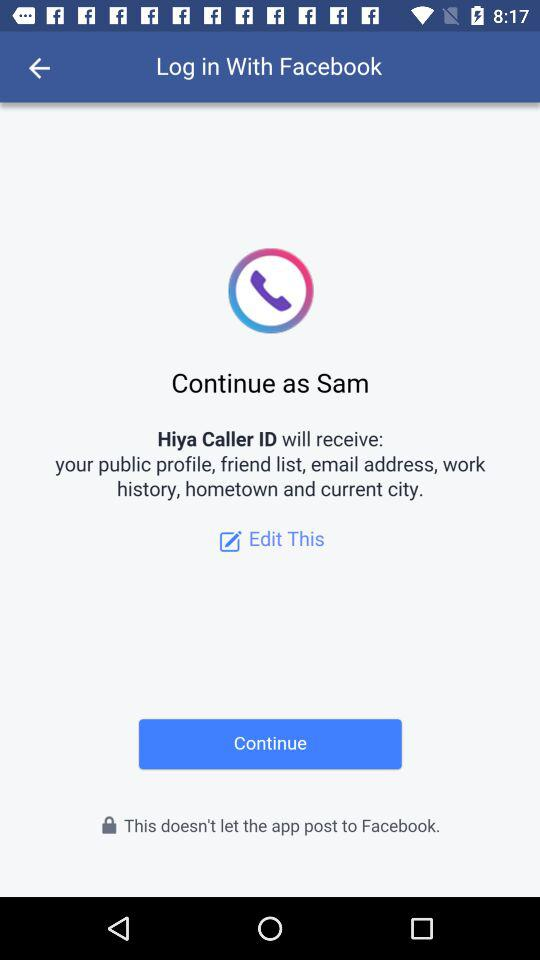Through what application can we log in? You can log in through "Facebook". 